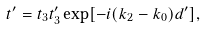Convert formula to latex. <formula><loc_0><loc_0><loc_500><loc_500>t ^ { \prime } = t _ { 3 } t _ { 3 } ^ { \prime } \exp [ - i ( k _ { 2 } - k _ { 0 } ) d ^ { \prime } ] ,</formula> 